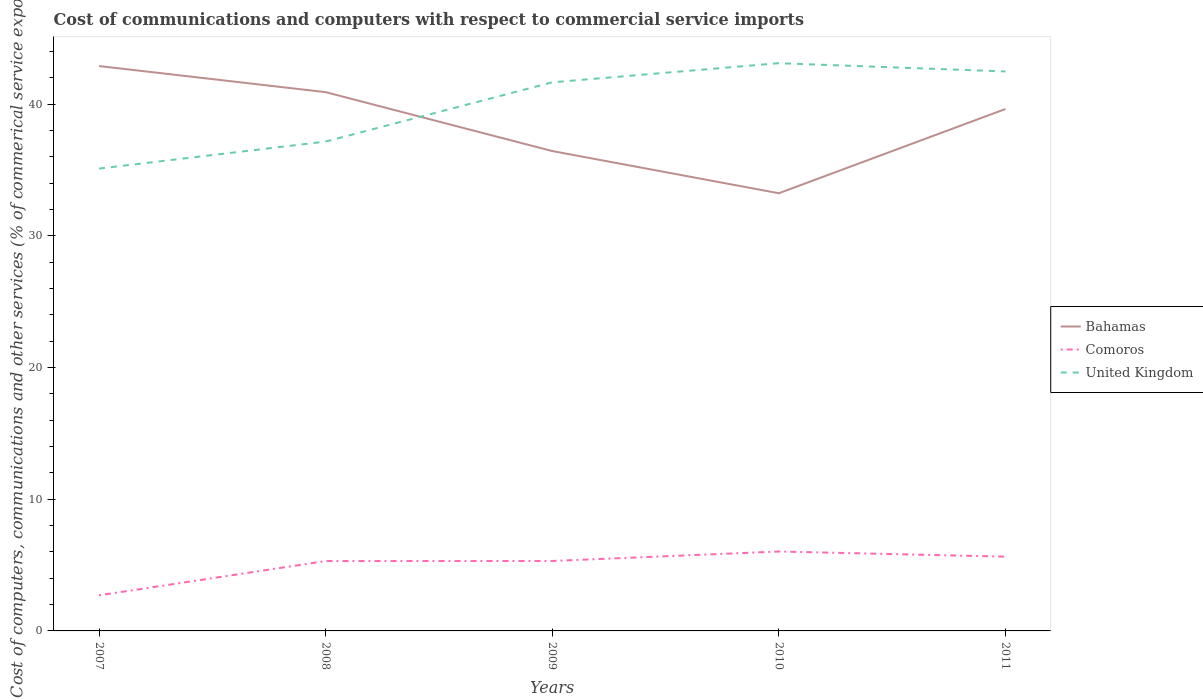How many different coloured lines are there?
Offer a terse response. 3. Is the number of lines equal to the number of legend labels?
Offer a terse response. Yes. Across all years, what is the maximum cost of communications and computers in United Kingdom?
Offer a terse response. 35.1. What is the total cost of communications and computers in United Kingdom in the graph?
Keep it short and to the point. -6.55. What is the difference between the highest and the second highest cost of communications and computers in United Kingdom?
Your answer should be compact. 8. What is the difference between the highest and the lowest cost of communications and computers in United Kingdom?
Provide a succinct answer. 3. How many lines are there?
Offer a very short reply. 3. How many years are there in the graph?
Provide a short and direct response. 5. What is the difference between two consecutive major ticks on the Y-axis?
Your response must be concise. 10. Are the values on the major ticks of Y-axis written in scientific E-notation?
Give a very brief answer. No. Does the graph contain any zero values?
Your answer should be compact. No. Does the graph contain grids?
Your response must be concise. No. How many legend labels are there?
Provide a succinct answer. 3. How are the legend labels stacked?
Provide a succinct answer. Vertical. What is the title of the graph?
Provide a short and direct response. Cost of communications and computers with respect to commercial service imports. Does "Rwanda" appear as one of the legend labels in the graph?
Make the answer very short. No. What is the label or title of the Y-axis?
Provide a succinct answer. Cost of computers, communications and other services (% of commerical service exports). What is the Cost of computers, communications and other services (% of commerical service exports) of Bahamas in 2007?
Your answer should be compact. 42.89. What is the Cost of computers, communications and other services (% of commerical service exports) of Comoros in 2007?
Make the answer very short. 2.71. What is the Cost of computers, communications and other services (% of commerical service exports) in United Kingdom in 2007?
Your response must be concise. 35.1. What is the Cost of computers, communications and other services (% of commerical service exports) in Bahamas in 2008?
Keep it short and to the point. 40.91. What is the Cost of computers, communications and other services (% of commerical service exports) in Comoros in 2008?
Offer a terse response. 5.3. What is the Cost of computers, communications and other services (% of commerical service exports) in United Kingdom in 2008?
Your response must be concise. 37.16. What is the Cost of computers, communications and other services (% of commerical service exports) in Bahamas in 2009?
Provide a short and direct response. 36.44. What is the Cost of computers, communications and other services (% of commerical service exports) of Comoros in 2009?
Your answer should be very brief. 5.31. What is the Cost of computers, communications and other services (% of commerical service exports) in United Kingdom in 2009?
Your response must be concise. 41.65. What is the Cost of computers, communications and other services (% of commerical service exports) of Bahamas in 2010?
Offer a terse response. 33.23. What is the Cost of computers, communications and other services (% of commerical service exports) of Comoros in 2010?
Keep it short and to the point. 6.03. What is the Cost of computers, communications and other services (% of commerical service exports) of United Kingdom in 2010?
Keep it short and to the point. 43.11. What is the Cost of computers, communications and other services (% of commerical service exports) of Bahamas in 2011?
Make the answer very short. 39.63. What is the Cost of computers, communications and other services (% of commerical service exports) in Comoros in 2011?
Provide a succinct answer. 5.64. What is the Cost of computers, communications and other services (% of commerical service exports) of United Kingdom in 2011?
Your answer should be compact. 42.48. Across all years, what is the maximum Cost of computers, communications and other services (% of commerical service exports) in Bahamas?
Give a very brief answer. 42.89. Across all years, what is the maximum Cost of computers, communications and other services (% of commerical service exports) of Comoros?
Offer a terse response. 6.03. Across all years, what is the maximum Cost of computers, communications and other services (% of commerical service exports) of United Kingdom?
Make the answer very short. 43.11. Across all years, what is the minimum Cost of computers, communications and other services (% of commerical service exports) of Bahamas?
Make the answer very short. 33.23. Across all years, what is the minimum Cost of computers, communications and other services (% of commerical service exports) in Comoros?
Provide a short and direct response. 2.71. Across all years, what is the minimum Cost of computers, communications and other services (% of commerical service exports) in United Kingdom?
Your answer should be very brief. 35.1. What is the total Cost of computers, communications and other services (% of commerical service exports) in Bahamas in the graph?
Your answer should be compact. 193.09. What is the total Cost of computers, communications and other services (% of commerical service exports) of Comoros in the graph?
Your answer should be compact. 24.99. What is the total Cost of computers, communications and other services (% of commerical service exports) in United Kingdom in the graph?
Make the answer very short. 199.5. What is the difference between the Cost of computers, communications and other services (% of commerical service exports) of Bahamas in 2007 and that in 2008?
Offer a very short reply. 1.98. What is the difference between the Cost of computers, communications and other services (% of commerical service exports) of Comoros in 2007 and that in 2008?
Your answer should be compact. -2.6. What is the difference between the Cost of computers, communications and other services (% of commerical service exports) in United Kingdom in 2007 and that in 2008?
Keep it short and to the point. -2.05. What is the difference between the Cost of computers, communications and other services (% of commerical service exports) in Bahamas in 2007 and that in 2009?
Ensure brevity in your answer.  6.45. What is the difference between the Cost of computers, communications and other services (% of commerical service exports) of Comoros in 2007 and that in 2009?
Your answer should be very brief. -2.6. What is the difference between the Cost of computers, communications and other services (% of commerical service exports) of United Kingdom in 2007 and that in 2009?
Your answer should be very brief. -6.55. What is the difference between the Cost of computers, communications and other services (% of commerical service exports) of Bahamas in 2007 and that in 2010?
Offer a terse response. 9.66. What is the difference between the Cost of computers, communications and other services (% of commerical service exports) in Comoros in 2007 and that in 2010?
Make the answer very short. -3.32. What is the difference between the Cost of computers, communications and other services (% of commerical service exports) in United Kingdom in 2007 and that in 2010?
Make the answer very short. -8. What is the difference between the Cost of computers, communications and other services (% of commerical service exports) of Bahamas in 2007 and that in 2011?
Offer a very short reply. 3.26. What is the difference between the Cost of computers, communications and other services (% of commerical service exports) in Comoros in 2007 and that in 2011?
Provide a short and direct response. -2.93. What is the difference between the Cost of computers, communications and other services (% of commerical service exports) in United Kingdom in 2007 and that in 2011?
Offer a terse response. -7.38. What is the difference between the Cost of computers, communications and other services (% of commerical service exports) of Bahamas in 2008 and that in 2009?
Your response must be concise. 4.47. What is the difference between the Cost of computers, communications and other services (% of commerical service exports) in Comoros in 2008 and that in 2009?
Give a very brief answer. -0.01. What is the difference between the Cost of computers, communications and other services (% of commerical service exports) in United Kingdom in 2008 and that in 2009?
Offer a terse response. -4.5. What is the difference between the Cost of computers, communications and other services (% of commerical service exports) in Bahamas in 2008 and that in 2010?
Make the answer very short. 7.68. What is the difference between the Cost of computers, communications and other services (% of commerical service exports) in Comoros in 2008 and that in 2010?
Offer a terse response. -0.73. What is the difference between the Cost of computers, communications and other services (% of commerical service exports) in United Kingdom in 2008 and that in 2010?
Offer a terse response. -5.95. What is the difference between the Cost of computers, communications and other services (% of commerical service exports) in Bahamas in 2008 and that in 2011?
Keep it short and to the point. 1.28. What is the difference between the Cost of computers, communications and other services (% of commerical service exports) in Comoros in 2008 and that in 2011?
Ensure brevity in your answer.  -0.34. What is the difference between the Cost of computers, communications and other services (% of commerical service exports) of United Kingdom in 2008 and that in 2011?
Provide a succinct answer. -5.32. What is the difference between the Cost of computers, communications and other services (% of commerical service exports) in Bahamas in 2009 and that in 2010?
Your answer should be very brief. 3.2. What is the difference between the Cost of computers, communications and other services (% of commerical service exports) in Comoros in 2009 and that in 2010?
Provide a short and direct response. -0.72. What is the difference between the Cost of computers, communications and other services (% of commerical service exports) of United Kingdom in 2009 and that in 2010?
Your answer should be very brief. -1.45. What is the difference between the Cost of computers, communications and other services (% of commerical service exports) of Bahamas in 2009 and that in 2011?
Your answer should be very brief. -3.19. What is the difference between the Cost of computers, communications and other services (% of commerical service exports) in Comoros in 2009 and that in 2011?
Make the answer very short. -0.33. What is the difference between the Cost of computers, communications and other services (% of commerical service exports) of United Kingdom in 2009 and that in 2011?
Give a very brief answer. -0.83. What is the difference between the Cost of computers, communications and other services (% of commerical service exports) in Bahamas in 2010 and that in 2011?
Your response must be concise. -6.39. What is the difference between the Cost of computers, communications and other services (% of commerical service exports) of Comoros in 2010 and that in 2011?
Your answer should be compact. 0.39. What is the difference between the Cost of computers, communications and other services (% of commerical service exports) in United Kingdom in 2010 and that in 2011?
Provide a short and direct response. 0.63. What is the difference between the Cost of computers, communications and other services (% of commerical service exports) of Bahamas in 2007 and the Cost of computers, communications and other services (% of commerical service exports) of Comoros in 2008?
Keep it short and to the point. 37.59. What is the difference between the Cost of computers, communications and other services (% of commerical service exports) of Bahamas in 2007 and the Cost of computers, communications and other services (% of commerical service exports) of United Kingdom in 2008?
Offer a terse response. 5.73. What is the difference between the Cost of computers, communications and other services (% of commerical service exports) in Comoros in 2007 and the Cost of computers, communications and other services (% of commerical service exports) in United Kingdom in 2008?
Offer a terse response. -34.45. What is the difference between the Cost of computers, communications and other services (% of commerical service exports) in Bahamas in 2007 and the Cost of computers, communications and other services (% of commerical service exports) in Comoros in 2009?
Ensure brevity in your answer.  37.58. What is the difference between the Cost of computers, communications and other services (% of commerical service exports) of Bahamas in 2007 and the Cost of computers, communications and other services (% of commerical service exports) of United Kingdom in 2009?
Make the answer very short. 1.24. What is the difference between the Cost of computers, communications and other services (% of commerical service exports) in Comoros in 2007 and the Cost of computers, communications and other services (% of commerical service exports) in United Kingdom in 2009?
Ensure brevity in your answer.  -38.95. What is the difference between the Cost of computers, communications and other services (% of commerical service exports) of Bahamas in 2007 and the Cost of computers, communications and other services (% of commerical service exports) of Comoros in 2010?
Offer a very short reply. 36.86. What is the difference between the Cost of computers, communications and other services (% of commerical service exports) in Bahamas in 2007 and the Cost of computers, communications and other services (% of commerical service exports) in United Kingdom in 2010?
Provide a succinct answer. -0.22. What is the difference between the Cost of computers, communications and other services (% of commerical service exports) in Comoros in 2007 and the Cost of computers, communications and other services (% of commerical service exports) in United Kingdom in 2010?
Ensure brevity in your answer.  -40.4. What is the difference between the Cost of computers, communications and other services (% of commerical service exports) in Bahamas in 2007 and the Cost of computers, communications and other services (% of commerical service exports) in Comoros in 2011?
Provide a short and direct response. 37.25. What is the difference between the Cost of computers, communications and other services (% of commerical service exports) in Bahamas in 2007 and the Cost of computers, communications and other services (% of commerical service exports) in United Kingdom in 2011?
Ensure brevity in your answer.  0.41. What is the difference between the Cost of computers, communications and other services (% of commerical service exports) in Comoros in 2007 and the Cost of computers, communications and other services (% of commerical service exports) in United Kingdom in 2011?
Your answer should be compact. -39.77. What is the difference between the Cost of computers, communications and other services (% of commerical service exports) in Bahamas in 2008 and the Cost of computers, communications and other services (% of commerical service exports) in Comoros in 2009?
Keep it short and to the point. 35.6. What is the difference between the Cost of computers, communications and other services (% of commerical service exports) of Bahamas in 2008 and the Cost of computers, communications and other services (% of commerical service exports) of United Kingdom in 2009?
Give a very brief answer. -0.75. What is the difference between the Cost of computers, communications and other services (% of commerical service exports) of Comoros in 2008 and the Cost of computers, communications and other services (% of commerical service exports) of United Kingdom in 2009?
Provide a succinct answer. -36.35. What is the difference between the Cost of computers, communications and other services (% of commerical service exports) of Bahamas in 2008 and the Cost of computers, communications and other services (% of commerical service exports) of Comoros in 2010?
Offer a very short reply. 34.88. What is the difference between the Cost of computers, communications and other services (% of commerical service exports) of Bahamas in 2008 and the Cost of computers, communications and other services (% of commerical service exports) of United Kingdom in 2010?
Your answer should be very brief. -2.2. What is the difference between the Cost of computers, communications and other services (% of commerical service exports) of Comoros in 2008 and the Cost of computers, communications and other services (% of commerical service exports) of United Kingdom in 2010?
Your answer should be very brief. -37.8. What is the difference between the Cost of computers, communications and other services (% of commerical service exports) of Bahamas in 2008 and the Cost of computers, communications and other services (% of commerical service exports) of Comoros in 2011?
Keep it short and to the point. 35.27. What is the difference between the Cost of computers, communications and other services (% of commerical service exports) of Bahamas in 2008 and the Cost of computers, communications and other services (% of commerical service exports) of United Kingdom in 2011?
Your response must be concise. -1.57. What is the difference between the Cost of computers, communications and other services (% of commerical service exports) of Comoros in 2008 and the Cost of computers, communications and other services (% of commerical service exports) of United Kingdom in 2011?
Keep it short and to the point. -37.17. What is the difference between the Cost of computers, communications and other services (% of commerical service exports) in Bahamas in 2009 and the Cost of computers, communications and other services (% of commerical service exports) in Comoros in 2010?
Make the answer very short. 30.41. What is the difference between the Cost of computers, communications and other services (% of commerical service exports) of Bahamas in 2009 and the Cost of computers, communications and other services (% of commerical service exports) of United Kingdom in 2010?
Keep it short and to the point. -6.67. What is the difference between the Cost of computers, communications and other services (% of commerical service exports) in Comoros in 2009 and the Cost of computers, communications and other services (% of commerical service exports) in United Kingdom in 2010?
Offer a very short reply. -37.8. What is the difference between the Cost of computers, communications and other services (% of commerical service exports) of Bahamas in 2009 and the Cost of computers, communications and other services (% of commerical service exports) of Comoros in 2011?
Provide a short and direct response. 30.8. What is the difference between the Cost of computers, communications and other services (% of commerical service exports) of Bahamas in 2009 and the Cost of computers, communications and other services (% of commerical service exports) of United Kingdom in 2011?
Make the answer very short. -6.04. What is the difference between the Cost of computers, communications and other services (% of commerical service exports) of Comoros in 2009 and the Cost of computers, communications and other services (% of commerical service exports) of United Kingdom in 2011?
Your answer should be compact. -37.17. What is the difference between the Cost of computers, communications and other services (% of commerical service exports) of Bahamas in 2010 and the Cost of computers, communications and other services (% of commerical service exports) of Comoros in 2011?
Your answer should be compact. 27.59. What is the difference between the Cost of computers, communications and other services (% of commerical service exports) of Bahamas in 2010 and the Cost of computers, communications and other services (% of commerical service exports) of United Kingdom in 2011?
Provide a succinct answer. -9.25. What is the difference between the Cost of computers, communications and other services (% of commerical service exports) of Comoros in 2010 and the Cost of computers, communications and other services (% of commerical service exports) of United Kingdom in 2011?
Provide a succinct answer. -36.45. What is the average Cost of computers, communications and other services (% of commerical service exports) in Bahamas per year?
Make the answer very short. 38.62. What is the average Cost of computers, communications and other services (% of commerical service exports) in Comoros per year?
Your answer should be compact. 5. What is the average Cost of computers, communications and other services (% of commerical service exports) in United Kingdom per year?
Offer a very short reply. 39.9. In the year 2007, what is the difference between the Cost of computers, communications and other services (% of commerical service exports) of Bahamas and Cost of computers, communications and other services (% of commerical service exports) of Comoros?
Give a very brief answer. 40.18. In the year 2007, what is the difference between the Cost of computers, communications and other services (% of commerical service exports) in Bahamas and Cost of computers, communications and other services (% of commerical service exports) in United Kingdom?
Your answer should be very brief. 7.79. In the year 2007, what is the difference between the Cost of computers, communications and other services (% of commerical service exports) in Comoros and Cost of computers, communications and other services (% of commerical service exports) in United Kingdom?
Keep it short and to the point. -32.4. In the year 2008, what is the difference between the Cost of computers, communications and other services (% of commerical service exports) in Bahamas and Cost of computers, communications and other services (% of commerical service exports) in Comoros?
Offer a terse response. 35.6. In the year 2008, what is the difference between the Cost of computers, communications and other services (% of commerical service exports) in Bahamas and Cost of computers, communications and other services (% of commerical service exports) in United Kingdom?
Your answer should be compact. 3.75. In the year 2008, what is the difference between the Cost of computers, communications and other services (% of commerical service exports) of Comoros and Cost of computers, communications and other services (% of commerical service exports) of United Kingdom?
Provide a short and direct response. -31.85. In the year 2009, what is the difference between the Cost of computers, communications and other services (% of commerical service exports) of Bahamas and Cost of computers, communications and other services (% of commerical service exports) of Comoros?
Keep it short and to the point. 31.13. In the year 2009, what is the difference between the Cost of computers, communications and other services (% of commerical service exports) in Bahamas and Cost of computers, communications and other services (% of commerical service exports) in United Kingdom?
Offer a very short reply. -5.22. In the year 2009, what is the difference between the Cost of computers, communications and other services (% of commerical service exports) in Comoros and Cost of computers, communications and other services (% of commerical service exports) in United Kingdom?
Give a very brief answer. -36.34. In the year 2010, what is the difference between the Cost of computers, communications and other services (% of commerical service exports) in Bahamas and Cost of computers, communications and other services (% of commerical service exports) in Comoros?
Offer a terse response. 27.2. In the year 2010, what is the difference between the Cost of computers, communications and other services (% of commerical service exports) of Bahamas and Cost of computers, communications and other services (% of commerical service exports) of United Kingdom?
Give a very brief answer. -9.87. In the year 2010, what is the difference between the Cost of computers, communications and other services (% of commerical service exports) of Comoros and Cost of computers, communications and other services (% of commerical service exports) of United Kingdom?
Give a very brief answer. -37.08. In the year 2011, what is the difference between the Cost of computers, communications and other services (% of commerical service exports) in Bahamas and Cost of computers, communications and other services (% of commerical service exports) in Comoros?
Your response must be concise. 33.99. In the year 2011, what is the difference between the Cost of computers, communications and other services (% of commerical service exports) of Bahamas and Cost of computers, communications and other services (% of commerical service exports) of United Kingdom?
Your response must be concise. -2.85. In the year 2011, what is the difference between the Cost of computers, communications and other services (% of commerical service exports) of Comoros and Cost of computers, communications and other services (% of commerical service exports) of United Kingdom?
Offer a very short reply. -36.84. What is the ratio of the Cost of computers, communications and other services (% of commerical service exports) of Bahamas in 2007 to that in 2008?
Make the answer very short. 1.05. What is the ratio of the Cost of computers, communications and other services (% of commerical service exports) in Comoros in 2007 to that in 2008?
Your answer should be very brief. 0.51. What is the ratio of the Cost of computers, communications and other services (% of commerical service exports) in United Kingdom in 2007 to that in 2008?
Ensure brevity in your answer.  0.94. What is the ratio of the Cost of computers, communications and other services (% of commerical service exports) of Bahamas in 2007 to that in 2009?
Your response must be concise. 1.18. What is the ratio of the Cost of computers, communications and other services (% of commerical service exports) in Comoros in 2007 to that in 2009?
Provide a short and direct response. 0.51. What is the ratio of the Cost of computers, communications and other services (% of commerical service exports) in United Kingdom in 2007 to that in 2009?
Offer a very short reply. 0.84. What is the ratio of the Cost of computers, communications and other services (% of commerical service exports) of Bahamas in 2007 to that in 2010?
Make the answer very short. 1.29. What is the ratio of the Cost of computers, communications and other services (% of commerical service exports) in Comoros in 2007 to that in 2010?
Provide a short and direct response. 0.45. What is the ratio of the Cost of computers, communications and other services (% of commerical service exports) of United Kingdom in 2007 to that in 2010?
Offer a very short reply. 0.81. What is the ratio of the Cost of computers, communications and other services (% of commerical service exports) in Bahamas in 2007 to that in 2011?
Your answer should be very brief. 1.08. What is the ratio of the Cost of computers, communications and other services (% of commerical service exports) in Comoros in 2007 to that in 2011?
Your answer should be compact. 0.48. What is the ratio of the Cost of computers, communications and other services (% of commerical service exports) in United Kingdom in 2007 to that in 2011?
Your response must be concise. 0.83. What is the ratio of the Cost of computers, communications and other services (% of commerical service exports) of Bahamas in 2008 to that in 2009?
Make the answer very short. 1.12. What is the ratio of the Cost of computers, communications and other services (% of commerical service exports) of United Kingdom in 2008 to that in 2009?
Offer a very short reply. 0.89. What is the ratio of the Cost of computers, communications and other services (% of commerical service exports) in Bahamas in 2008 to that in 2010?
Make the answer very short. 1.23. What is the ratio of the Cost of computers, communications and other services (% of commerical service exports) in Comoros in 2008 to that in 2010?
Offer a terse response. 0.88. What is the ratio of the Cost of computers, communications and other services (% of commerical service exports) of United Kingdom in 2008 to that in 2010?
Keep it short and to the point. 0.86. What is the ratio of the Cost of computers, communications and other services (% of commerical service exports) in Bahamas in 2008 to that in 2011?
Make the answer very short. 1.03. What is the ratio of the Cost of computers, communications and other services (% of commerical service exports) in Comoros in 2008 to that in 2011?
Offer a terse response. 0.94. What is the ratio of the Cost of computers, communications and other services (% of commerical service exports) in United Kingdom in 2008 to that in 2011?
Provide a succinct answer. 0.87. What is the ratio of the Cost of computers, communications and other services (% of commerical service exports) in Bahamas in 2009 to that in 2010?
Your response must be concise. 1.1. What is the ratio of the Cost of computers, communications and other services (% of commerical service exports) in Comoros in 2009 to that in 2010?
Your answer should be compact. 0.88. What is the ratio of the Cost of computers, communications and other services (% of commerical service exports) in United Kingdom in 2009 to that in 2010?
Your answer should be very brief. 0.97. What is the ratio of the Cost of computers, communications and other services (% of commerical service exports) in Bahamas in 2009 to that in 2011?
Your response must be concise. 0.92. What is the ratio of the Cost of computers, communications and other services (% of commerical service exports) of Comoros in 2009 to that in 2011?
Ensure brevity in your answer.  0.94. What is the ratio of the Cost of computers, communications and other services (% of commerical service exports) in United Kingdom in 2009 to that in 2011?
Your answer should be compact. 0.98. What is the ratio of the Cost of computers, communications and other services (% of commerical service exports) of Bahamas in 2010 to that in 2011?
Keep it short and to the point. 0.84. What is the ratio of the Cost of computers, communications and other services (% of commerical service exports) of Comoros in 2010 to that in 2011?
Your answer should be very brief. 1.07. What is the ratio of the Cost of computers, communications and other services (% of commerical service exports) in United Kingdom in 2010 to that in 2011?
Offer a very short reply. 1.01. What is the difference between the highest and the second highest Cost of computers, communications and other services (% of commerical service exports) in Bahamas?
Your answer should be compact. 1.98. What is the difference between the highest and the second highest Cost of computers, communications and other services (% of commerical service exports) of Comoros?
Offer a terse response. 0.39. What is the difference between the highest and the second highest Cost of computers, communications and other services (% of commerical service exports) in United Kingdom?
Your response must be concise. 0.63. What is the difference between the highest and the lowest Cost of computers, communications and other services (% of commerical service exports) in Bahamas?
Make the answer very short. 9.66. What is the difference between the highest and the lowest Cost of computers, communications and other services (% of commerical service exports) in Comoros?
Your response must be concise. 3.32. What is the difference between the highest and the lowest Cost of computers, communications and other services (% of commerical service exports) of United Kingdom?
Offer a very short reply. 8. 